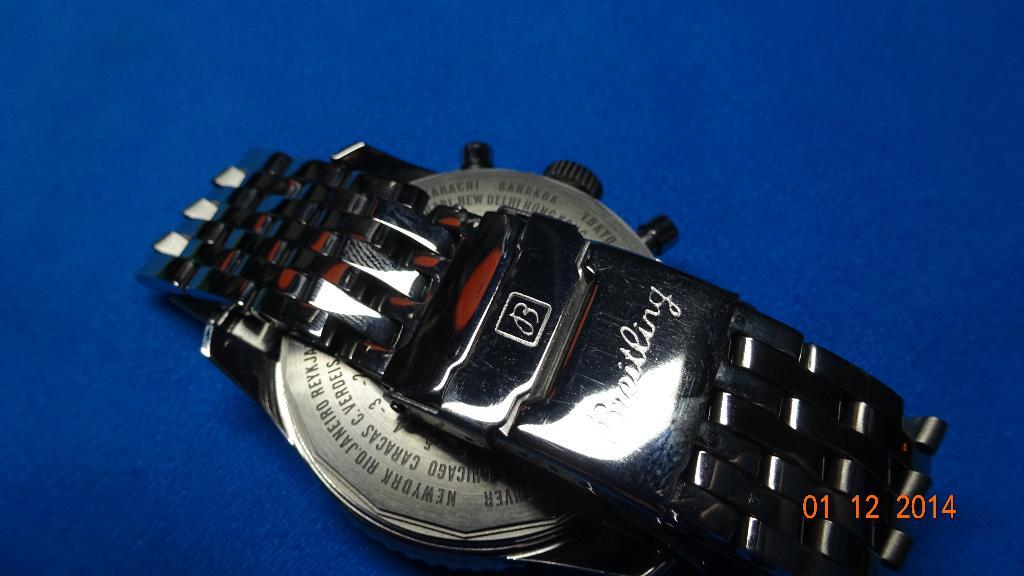What object is the main focus of the image? There is a wrist watch in the image. Where is the wrist watch placed? The wrist watch is placed on a surface. How is the wrist watch positioned in the image? The wrist watch is located in the center of the image. What type of coast can be seen in the background of the image? There is no coast visible in the image; it only features a wrist watch placed on a surface. 